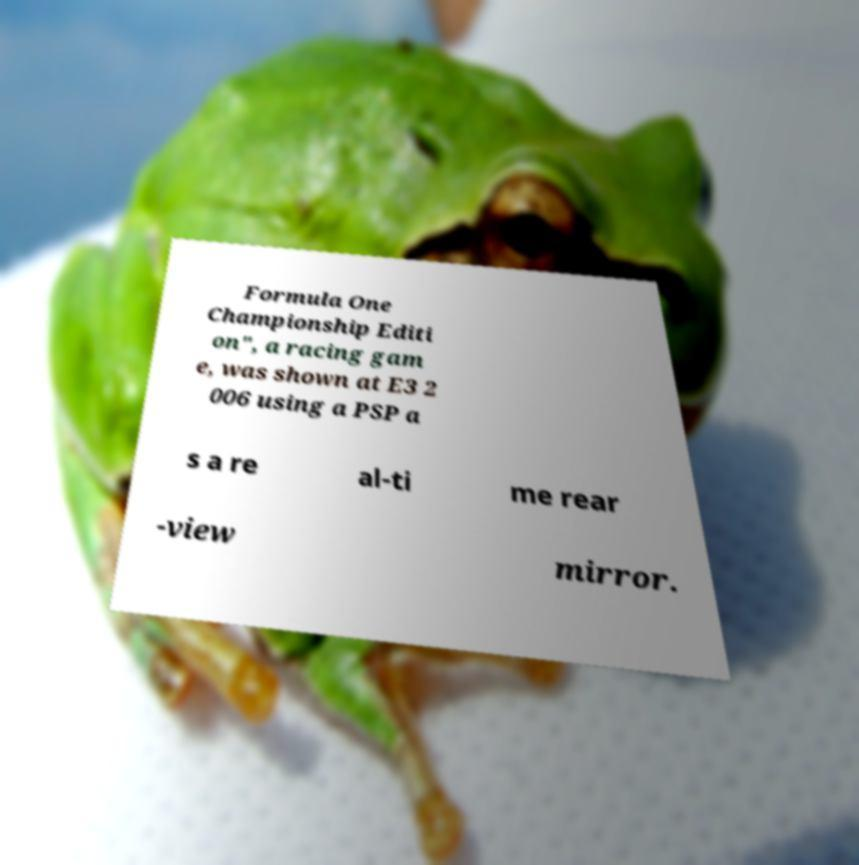Can you read and provide the text displayed in the image?This photo seems to have some interesting text. Can you extract and type it out for me? Formula One Championship Editi on", a racing gam e, was shown at E3 2 006 using a PSP a s a re al-ti me rear -view mirror. 